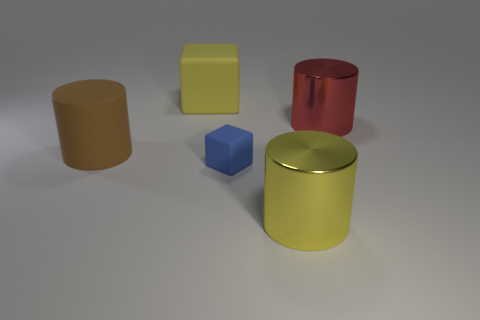Subtract all large metal cylinders. How many cylinders are left? 1 Add 5 big cylinders. How many objects exist? 10 Subtract all red cylinders. How many cylinders are left? 2 Subtract all cubes. How many objects are left? 3 Subtract all red balls. How many purple cylinders are left? 0 Subtract all big yellow rubber things. Subtract all tiny purple cubes. How many objects are left? 4 Add 1 metal cylinders. How many metal cylinders are left? 3 Add 1 big yellow matte cubes. How many big yellow matte cubes exist? 2 Subtract 0 cyan cubes. How many objects are left? 5 Subtract all gray cylinders. Subtract all green cubes. How many cylinders are left? 3 